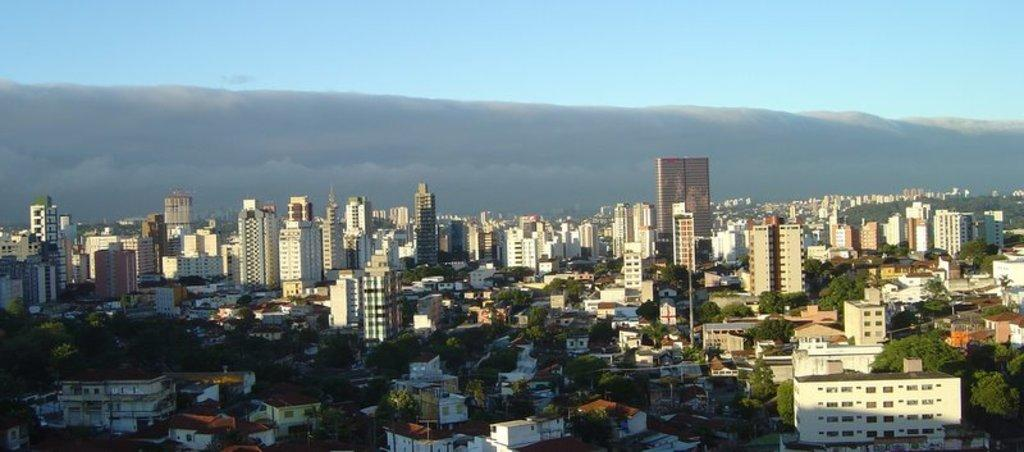What type of structures can be seen in the image? There are buildings in the image. What feature is common among some of the buildings? There are windows in the image. What type of natural elements are present in the image? There are trees in the image. What type of man-made objects can be seen in the image? There are poles in the image. How would you describe the color of the sky in the image? The sky is grey and blue in color. Can you tell me how many sisters are visible in the image? There are no sisters present in the image. What type of vegetable is being used to decorate the buildings in the image? There are no vegetables present in the image; it features buildings, windows, trees, poles, and a grey and blue sky. 